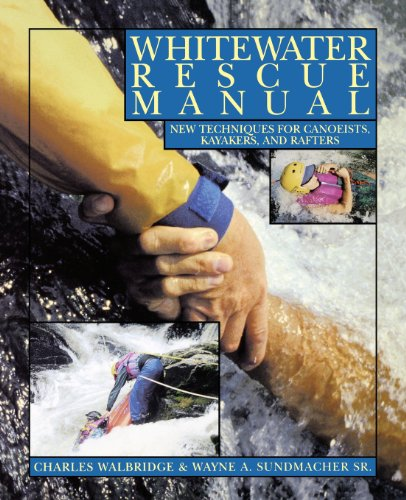Is this book related to Computers & Technology? No, this book does not pertain to the 'Computers & Technology' area; it is specifically focused on outdoor water sports and rescue techniques. 